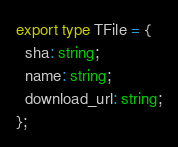Convert code to text. <code><loc_0><loc_0><loc_500><loc_500><_TypeScript_>export type TFile = {
  sha: string;
  name: string;
  download_url: string;
};
</code> 